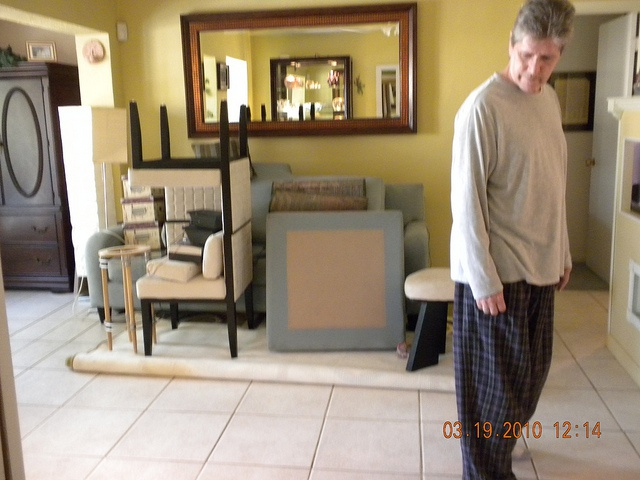Describe the objects in this image and their specific colors. I can see people in olive, black, tan, and gray tones, chair in olive, black, and tan tones, couch in olive, gray, black, darkgreen, and darkgray tones, chair in olive, black, and tan tones, and chair in olive, black, tan, and gray tones in this image. 